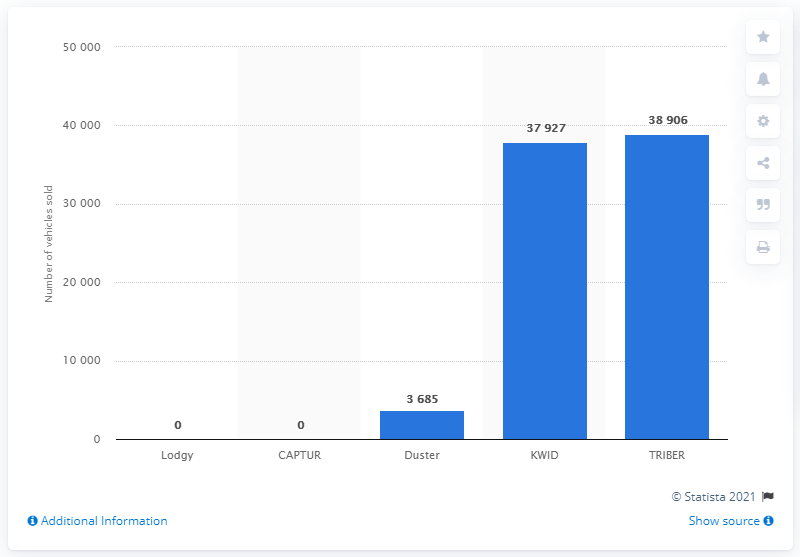Give some essential details in this illustration. In 2020, a total of 38,906 Renault TRIBER units were sold in India. 